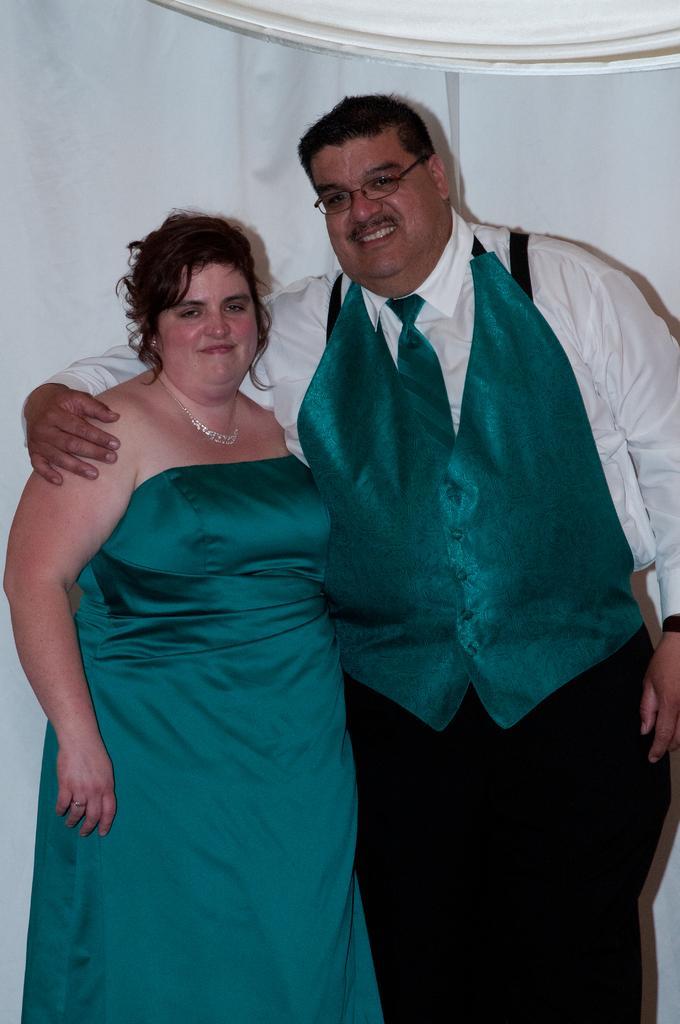Can you describe this image briefly? In this picture we can see a man and a woman standing and smiling. 